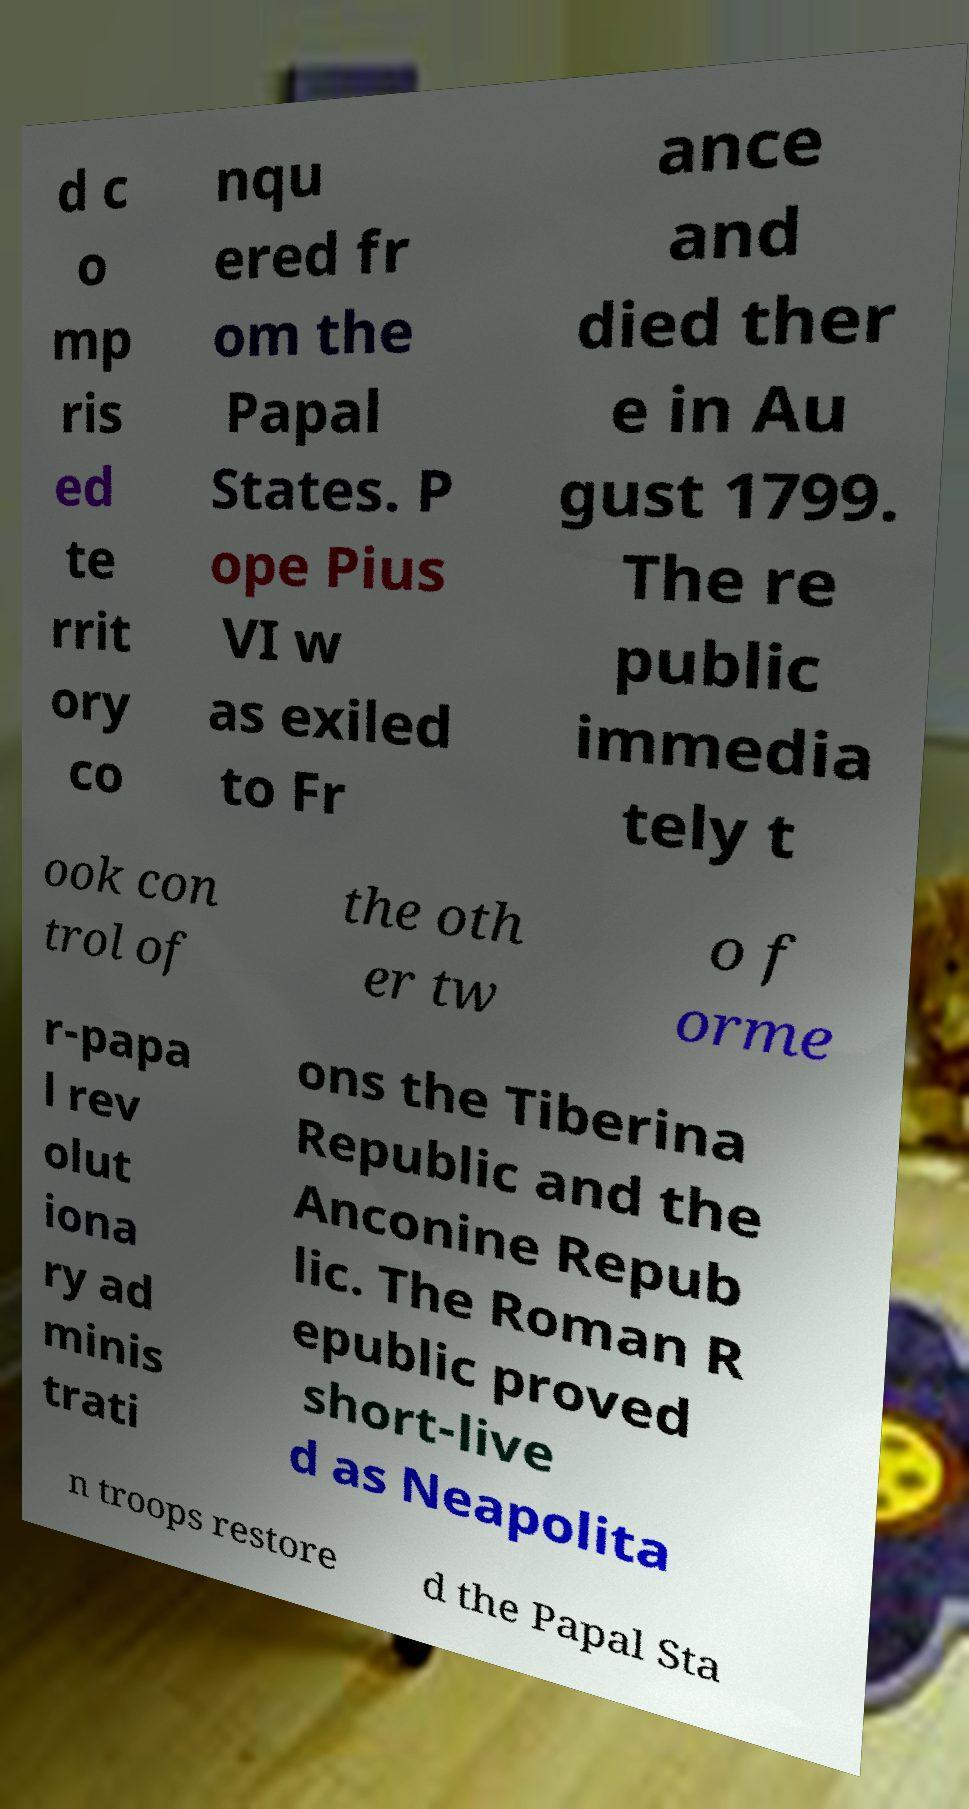There's text embedded in this image that I need extracted. Can you transcribe it verbatim? d c o mp ris ed te rrit ory co nqu ered fr om the Papal States. P ope Pius VI w as exiled to Fr ance and died ther e in Au gust 1799. The re public immedia tely t ook con trol of the oth er tw o f orme r-papa l rev olut iona ry ad minis trati ons the Tiberina Republic and the Anconine Repub lic. The Roman R epublic proved short-live d as Neapolita n troops restore d the Papal Sta 